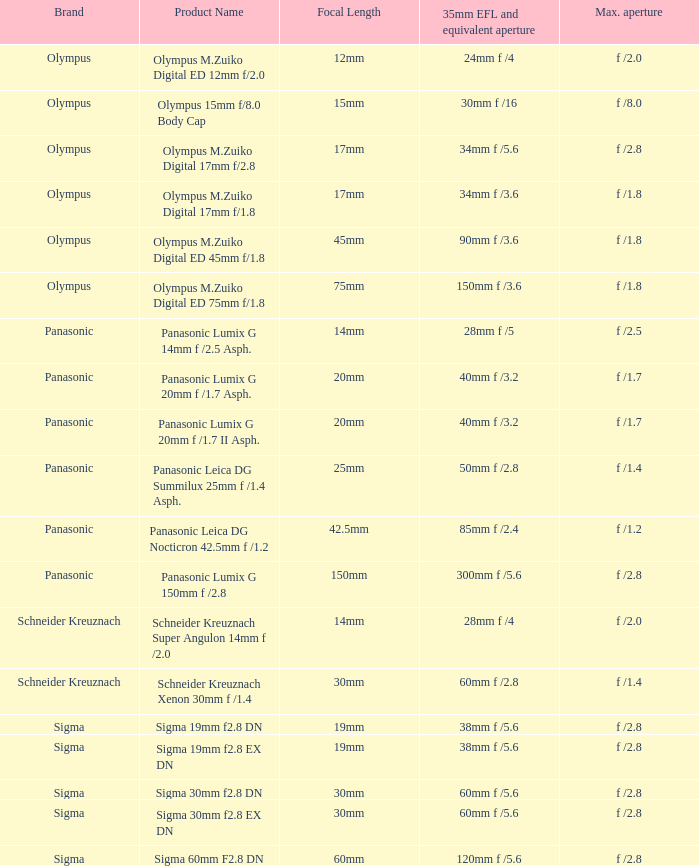What is the company behind the sigma 30mm f Sigma. 